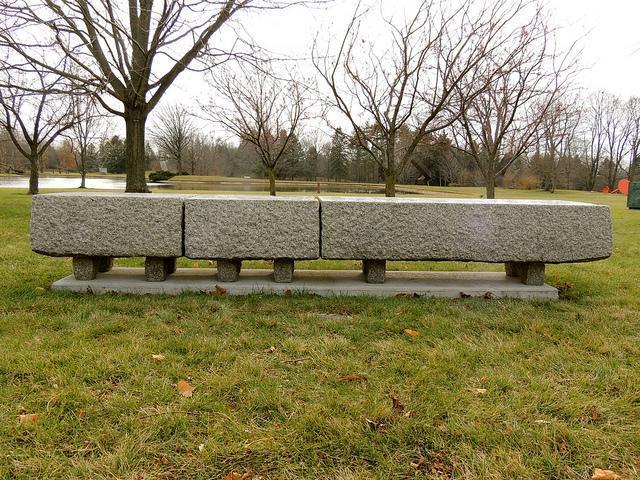How many people are wearing a green hat?
Give a very brief answer. 0. 